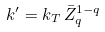<formula> <loc_0><loc_0><loc_500><loc_500>k ^ { \prime } = k _ { T } \, \bar { Z } _ { q } ^ { 1 - q }</formula> 